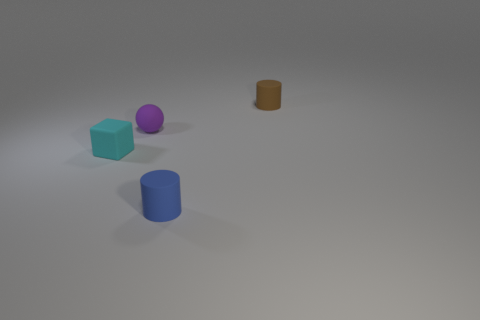Imagine these objects in a real-world context - where do you think they would belong? Their simplistic shapes and colors suggest they could be part of an educational toy set designed to teach children about geometry and color recognition. 